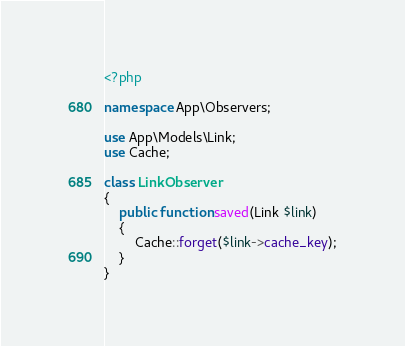<code> <loc_0><loc_0><loc_500><loc_500><_PHP_><?php

namespace App\Observers;

use App\Models\Link;
use Cache;

class LinkObserver
{
    public function saved(Link $link)
    {
        Cache::forget($link->cache_key);
    }
}</code> 